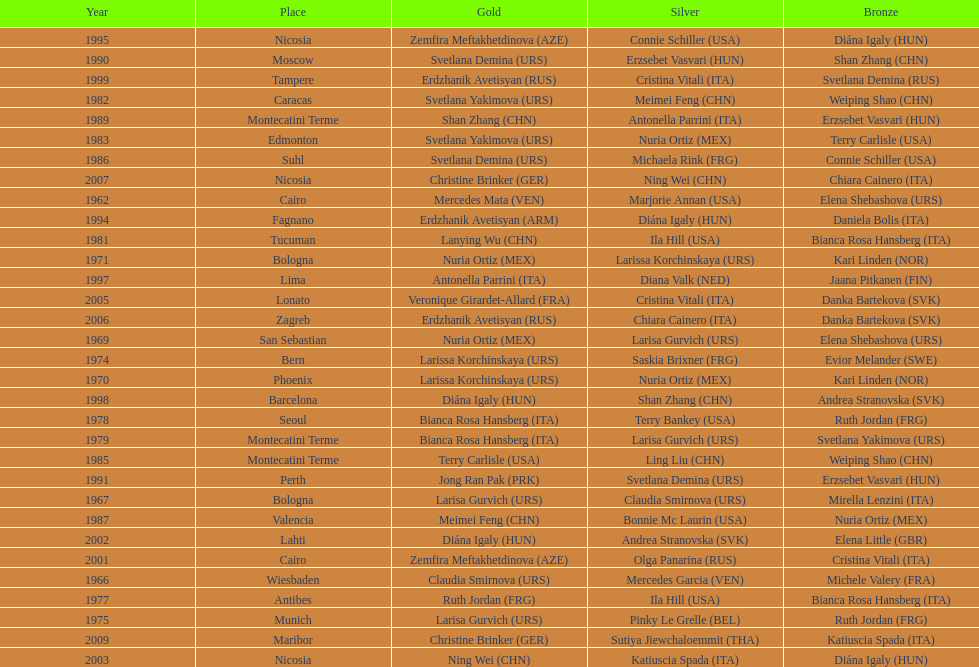What is the total of silver for cairo 0. 